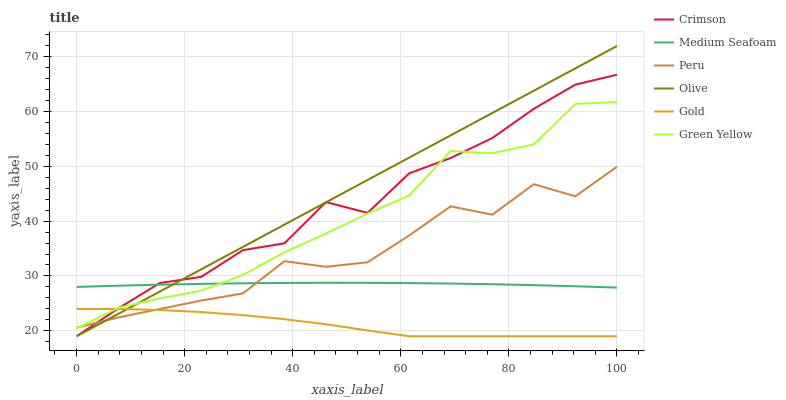Does Gold have the minimum area under the curve?
Answer yes or no. Yes. Does Olive have the maximum area under the curve?
Answer yes or no. Yes. Does Peru have the minimum area under the curve?
Answer yes or no. No. Does Peru have the maximum area under the curve?
Answer yes or no. No. Is Olive the smoothest?
Answer yes or no. Yes. Is Peru the roughest?
Answer yes or no. Yes. Is Peru the smoothest?
Answer yes or no. No. Is Olive the roughest?
Answer yes or no. No. Does Gold have the lowest value?
Answer yes or no. Yes. Does Peru have the lowest value?
Answer yes or no. No. Does Olive have the highest value?
Answer yes or no. Yes. Does Peru have the highest value?
Answer yes or no. No. Is Gold less than Medium Seafoam?
Answer yes or no. Yes. Is Medium Seafoam greater than Gold?
Answer yes or no. Yes. Does Olive intersect Green Yellow?
Answer yes or no. Yes. Is Olive less than Green Yellow?
Answer yes or no. No. Is Olive greater than Green Yellow?
Answer yes or no. No. Does Gold intersect Medium Seafoam?
Answer yes or no. No. 